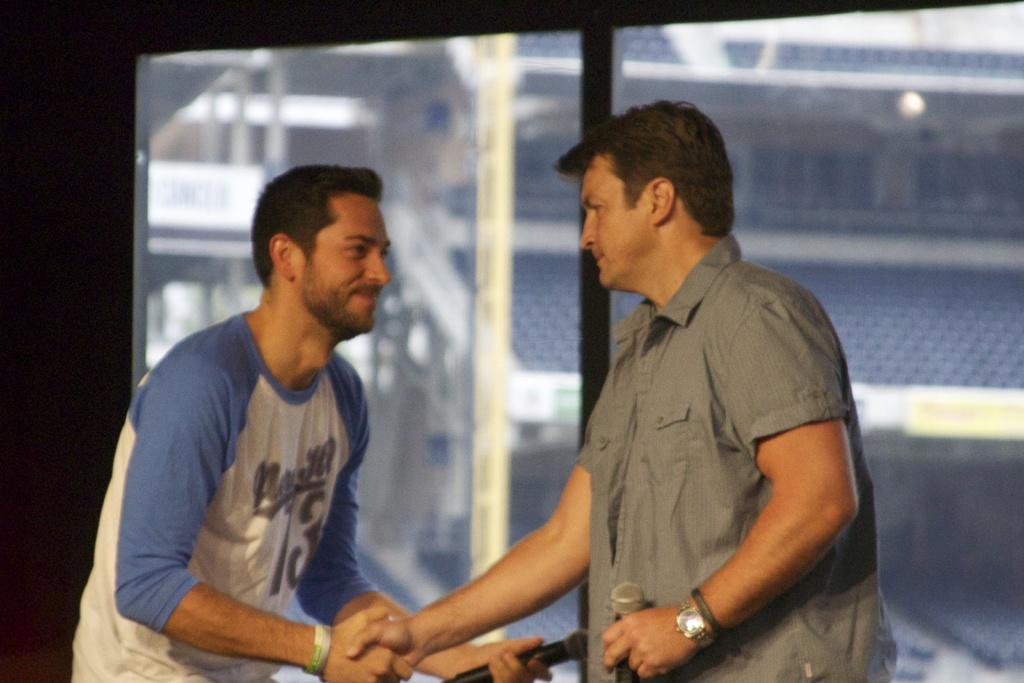Describe this image in one or two sentences. In this image there are two persons standing and holding mikes, and at the background there is a stadium with poles and chairs. 